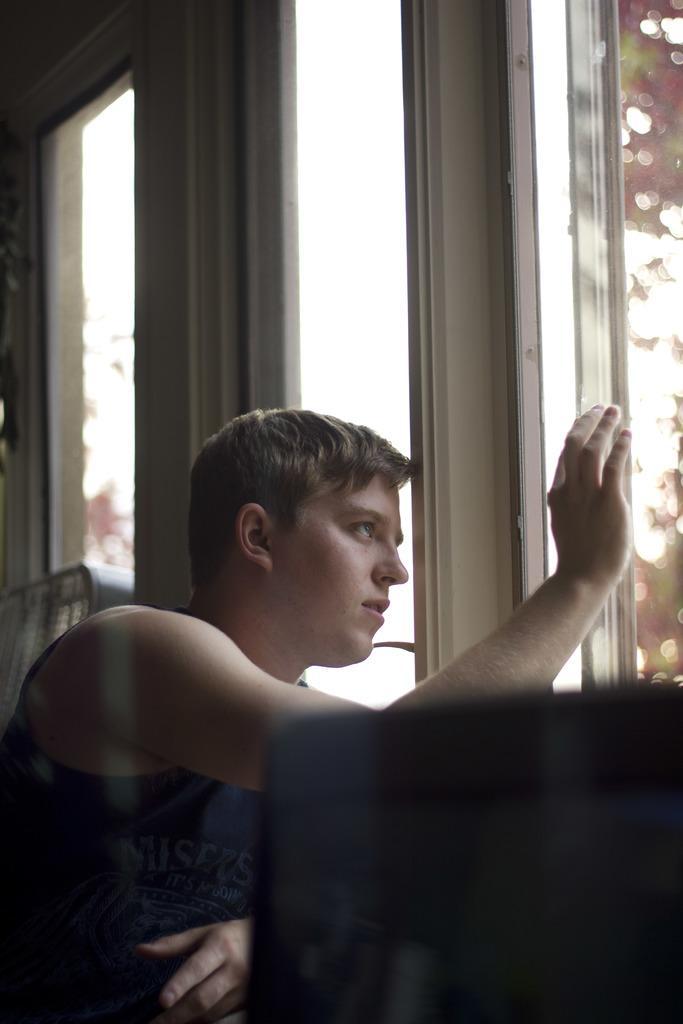How would you summarize this image in a sentence or two? On the right side of the picture we can see the windows. In this picture we can see the objects. This picture is mainly highlighted with a man and he kept his hand on the window glass. 